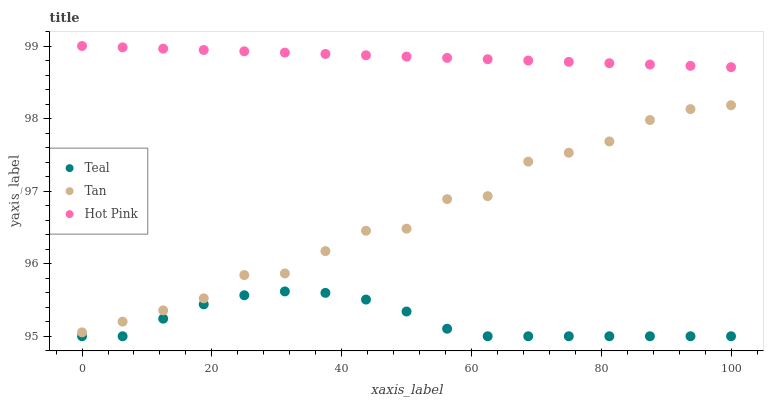Does Teal have the minimum area under the curve?
Answer yes or no. Yes. Does Hot Pink have the maximum area under the curve?
Answer yes or no. Yes. Does Hot Pink have the minimum area under the curve?
Answer yes or no. No. Does Teal have the maximum area under the curve?
Answer yes or no. No. Is Hot Pink the smoothest?
Answer yes or no. Yes. Is Tan the roughest?
Answer yes or no. Yes. Is Teal the smoothest?
Answer yes or no. No. Is Teal the roughest?
Answer yes or no. No. Does Teal have the lowest value?
Answer yes or no. Yes. Does Hot Pink have the lowest value?
Answer yes or no. No. Does Hot Pink have the highest value?
Answer yes or no. Yes. Does Teal have the highest value?
Answer yes or no. No. Is Teal less than Hot Pink?
Answer yes or no. Yes. Is Tan greater than Teal?
Answer yes or no. Yes. Does Teal intersect Hot Pink?
Answer yes or no. No. 